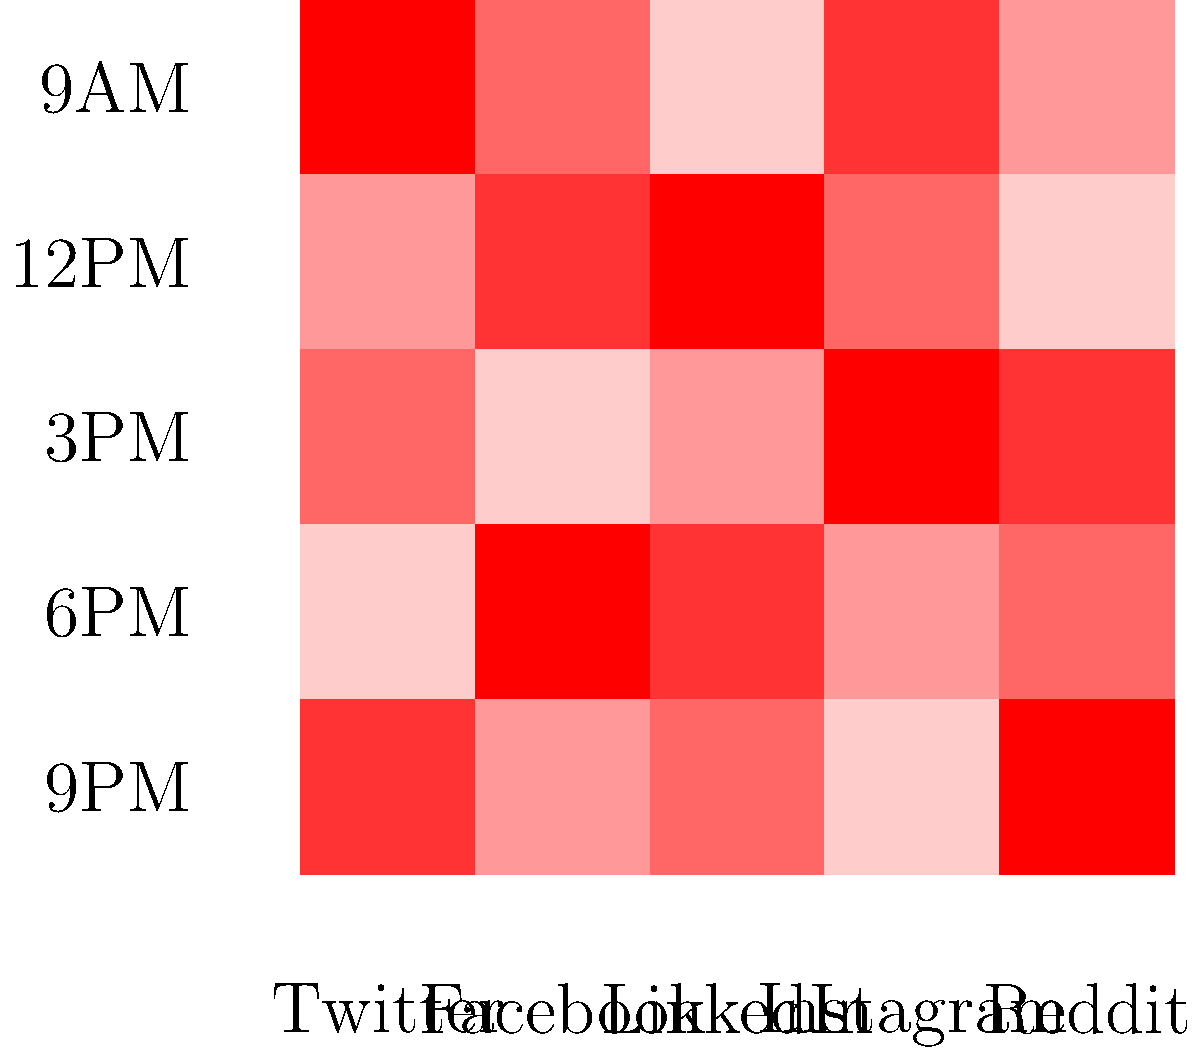Based on the heat map showing community activity across different social media platforms at various times of the day, which platform demonstrates the highest overall engagement, and at what time does this peak occur? To answer this question, we need to analyze the heat map systematically:

1. Understand the heat map:
   - Rows represent different times of the day (9AM to 9PM)
   - Columns represent different social media platforms
   - Darker red indicates higher activity

2. Examine each platform's activity levels:
   - Twitter: Moderate activity, peaks at 6PM
   - Facebook: High activity, peaks at 3PM
   - LinkedIn: Moderate activity, peaks at 6PM
   - Instagram: High activity, peaks at 12PM
   - Reddit: Moderate activity, peaks at 9AM

3. Compare overall engagement:
   - Facebook and Instagram show the darkest red cells, indicating highest overall engagement

4. Identify the highest peak:
   - Facebook's darkest red cell is at 3PM
   - Instagram's darkest red cell is at 12PM
   - Facebook's 3PM cell appears slightly darker

5. Conclusion:
   Facebook shows the highest overall engagement, with peak activity occurring at 3PM.
Answer: Facebook at 3PM 